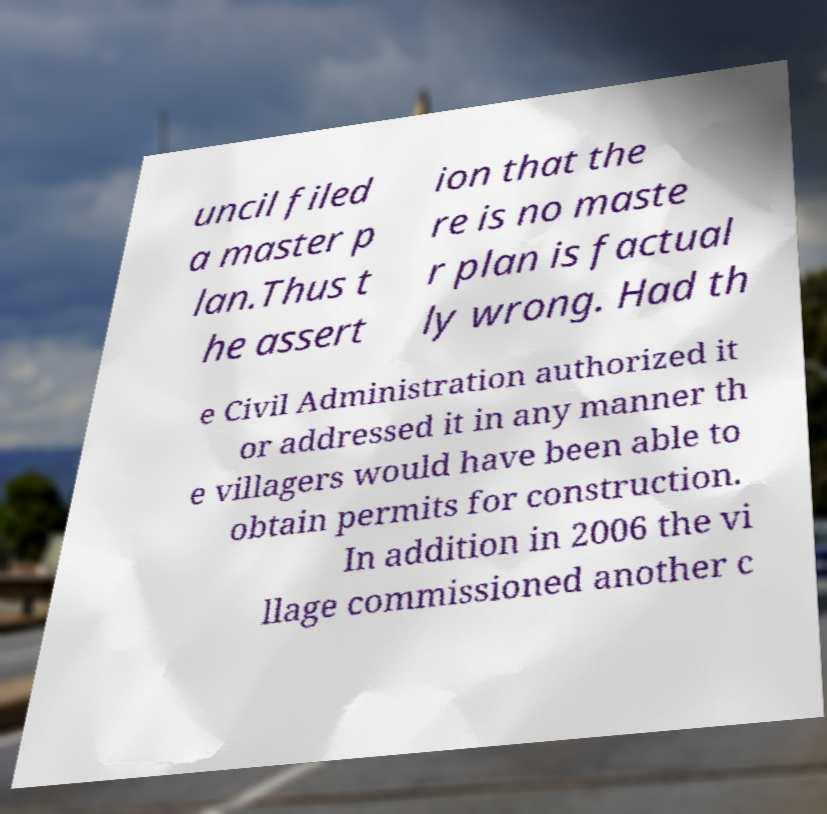Please read and relay the text visible in this image. What does it say? uncil filed a master p lan.Thus t he assert ion that the re is no maste r plan is factual ly wrong. Had th e Civil Administration authorized it or addressed it in any manner th e villagers would have been able to obtain permits for construction. In addition in 2006 the vi llage commissioned another c 